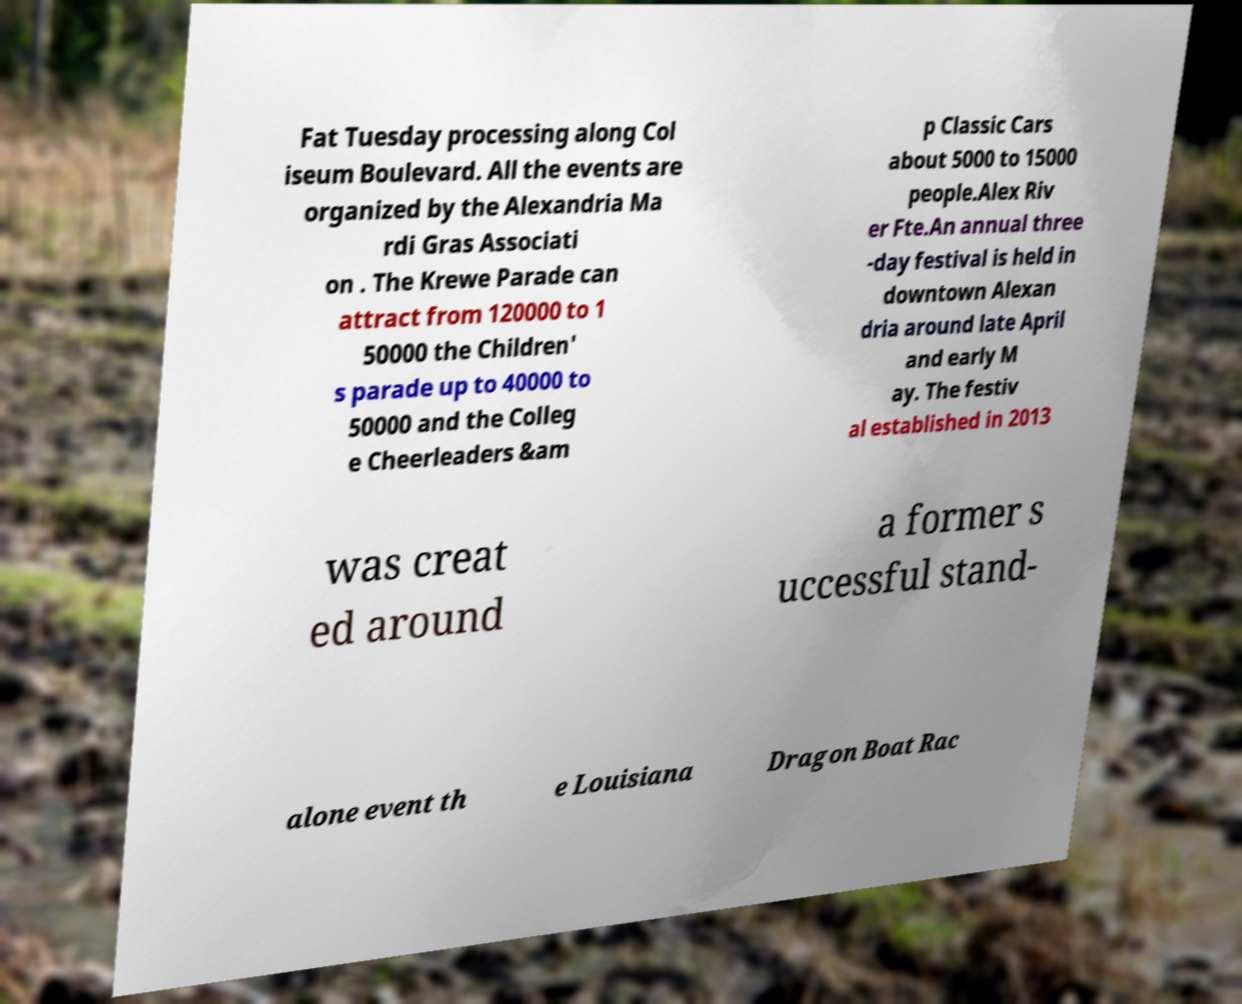Can you read and provide the text displayed in the image?This photo seems to have some interesting text. Can you extract and type it out for me? Fat Tuesday processing along Col iseum Boulevard. All the events are organized by the Alexandria Ma rdi Gras Associati on . The Krewe Parade can attract from 120000 to 1 50000 the Children' s parade up to 40000 to 50000 and the Colleg e Cheerleaders &am p Classic Cars about 5000 to 15000 people.Alex Riv er Fte.An annual three -day festival is held in downtown Alexan dria around late April and early M ay. The festiv al established in 2013 was creat ed around a former s uccessful stand- alone event th e Louisiana Dragon Boat Rac 